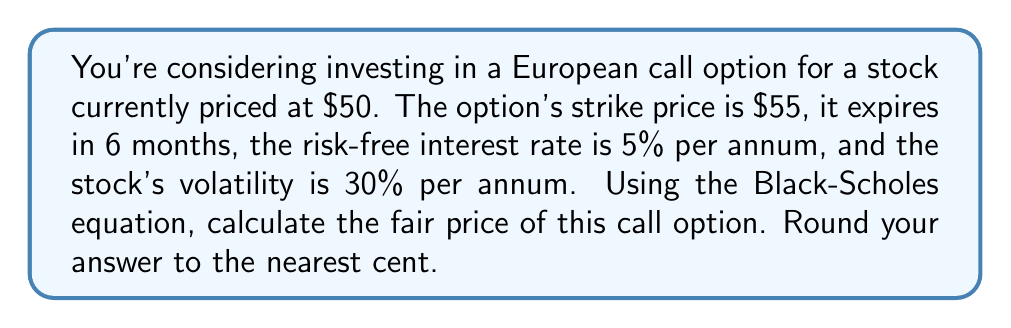Show me your answer to this math problem. To solve this problem, we'll use the Black-Scholes equation for pricing European call options:

$$C = S_0N(d_1) - Ke^{-rT}N(d_2)$$

Where:
$C$ = Call option price
$S_0$ = Current stock price
$K$ = Strike price
$r$ = Risk-free interest rate
$T$ = Time to expiration (in years)
$N(x)$ = Cumulative standard normal distribution function
$\sigma$ = Stock price volatility

And:

$$d_1 = \frac{\ln(S_0/K) + (r + \sigma^2/2)T}{\sigma\sqrt{T}}$$
$$d_2 = d_1 - \sigma\sqrt{T}$$

Step 1: Calculate $d_1$ and $d_2$

Given:
$S_0 = 50$
$K = 55$
$r = 0.05$
$T = 0.5$ (6 months = 0.5 years)
$\sigma = 0.30$

First, calculate $d_1$:

$$d_1 = \frac{\ln(50/55) + (0.05 + 0.30^2/2) * 0.5}{0.30\sqrt{0.5}} \approx -0.0987$$

Then, calculate $d_2$:

$$d_2 = -0.0987 - 0.30\sqrt{0.5} \approx -0.3108$$

Step 2: Calculate $N(d_1)$ and $N(d_2)$

Using a standard normal distribution table or calculator:

$N(d_1) = N(-0.0987) \approx 0.4607$
$N(d_2) = N(-0.3108) \approx 0.3780$

Step 3: Apply the Black-Scholes formula

$$C = 50 * 0.4607 - 55 * e^{-0.05 * 0.5} * 0.3780$$

$$C = 23.035 - 20.4755 = 2.5595$$

Step 4: Round to the nearest cent

$C \approx 2.56$
Answer: $2.56 